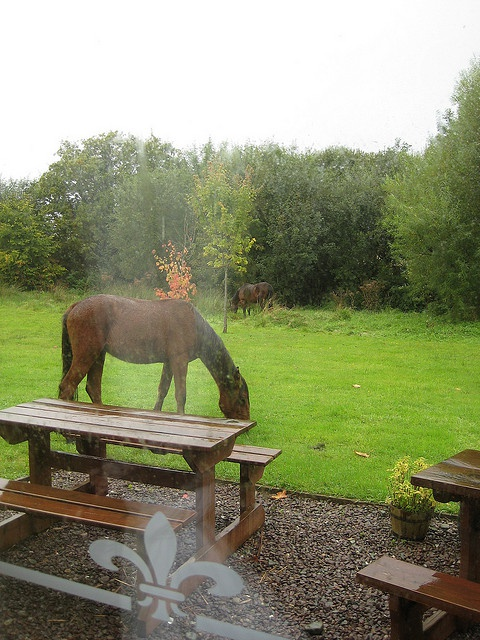Describe the objects in this image and their specific colors. I can see dining table in white, black, gray, and darkgray tones, horse in white, gray, and maroon tones, bench in white, black, maroon, gray, and olive tones, bench in white, darkgray, maroon, and gray tones, and dining table in white, black, olive, and gray tones in this image. 